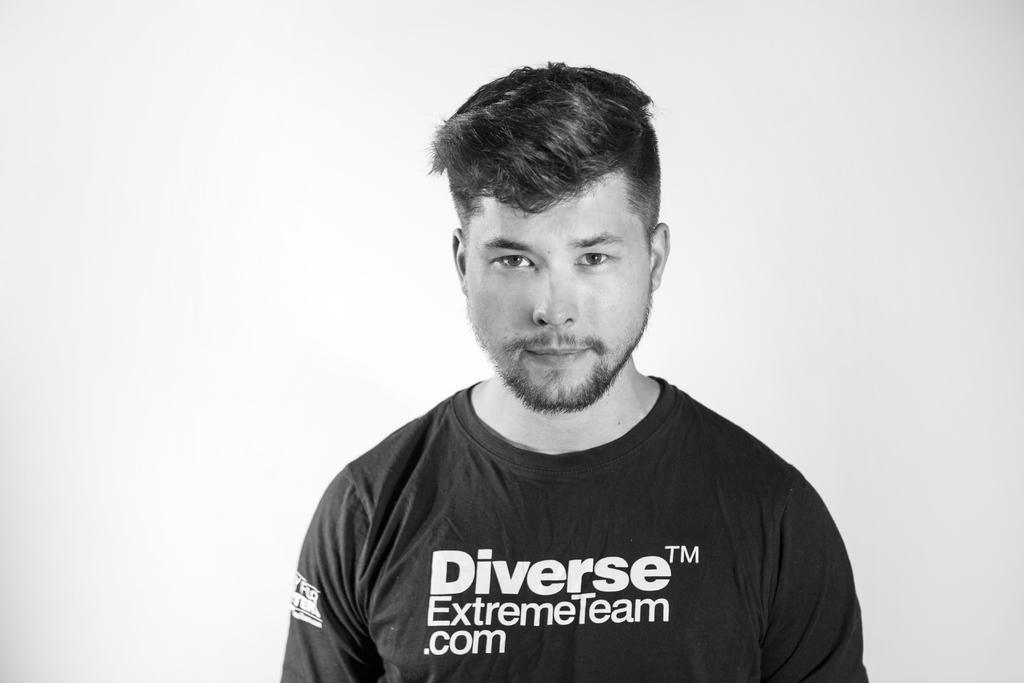How would you summarize this image in a sentence or two? It is a black and white image, there is a person and he is standing in front of a white background. 